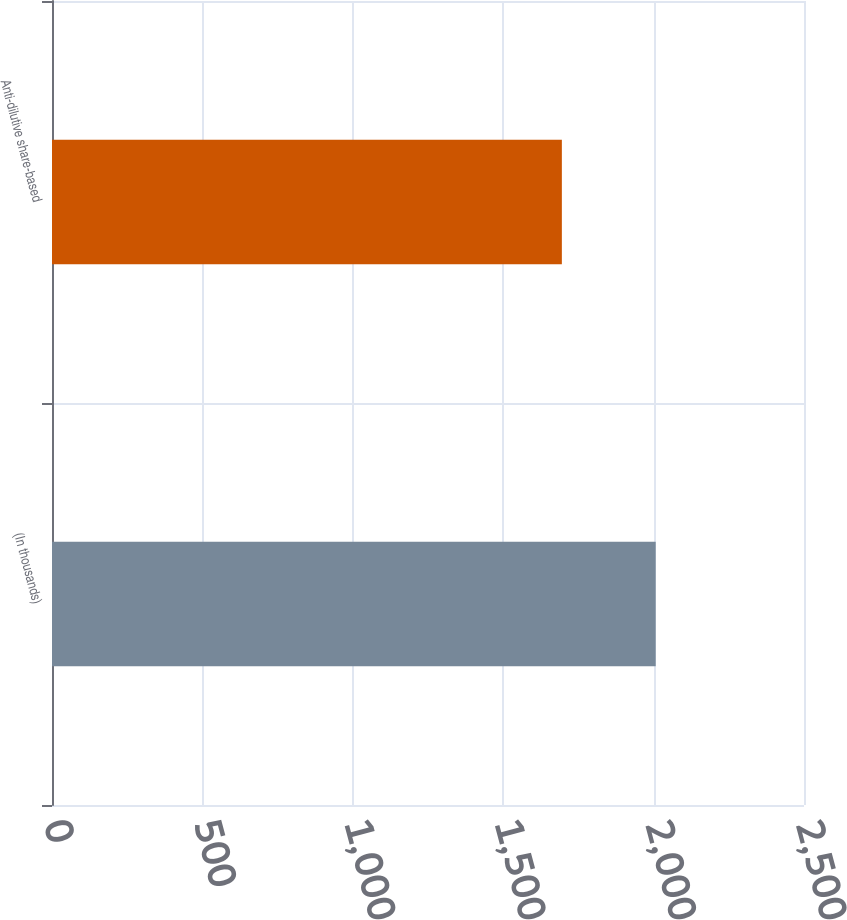Convert chart. <chart><loc_0><loc_0><loc_500><loc_500><bar_chart><fcel>(In thousands)<fcel>Anti-dilutive share-based<nl><fcel>2007<fcel>1695<nl></chart> 